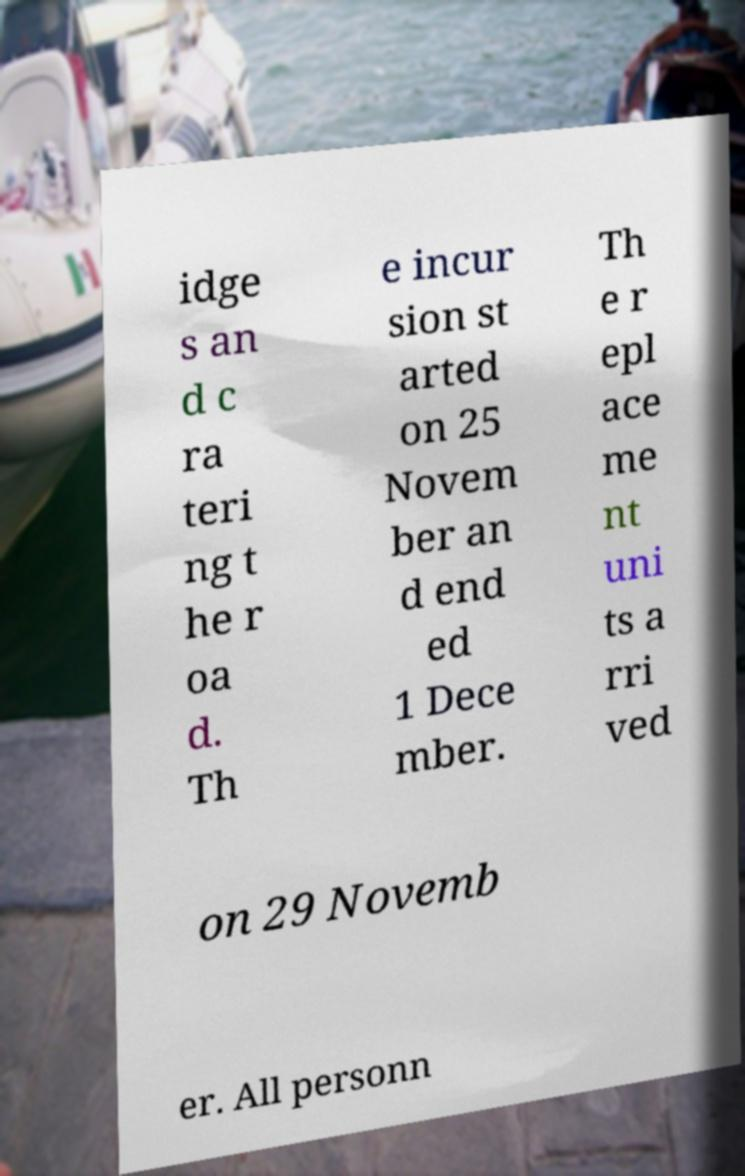For documentation purposes, I need the text within this image transcribed. Could you provide that? idge s an d c ra teri ng t he r oa d. Th e incur sion st arted on 25 Novem ber an d end ed 1 Dece mber. Th e r epl ace me nt uni ts a rri ved on 29 Novemb er. All personn 